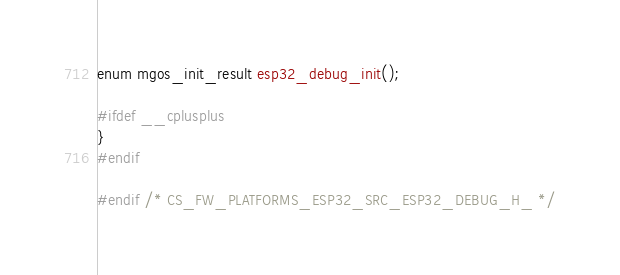Convert code to text. <code><loc_0><loc_0><loc_500><loc_500><_C_>enum mgos_init_result esp32_debug_init();

#ifdef __cplusplus
}
#endif

#endif /* CS_FW_PLATFORMS_ESP32_SRC_ESP32_DEBUG_H_ */
</code> 